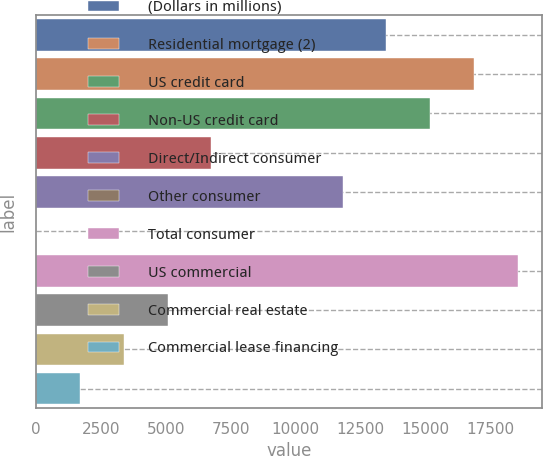Convert chart. <chart><loc_0><loc_0><loc_500><loc_500><bar_chart><fcel>(Dollars in millions)<fcel>Residential mortgage (2)<fcel>US credit card<fcel>Non-US credit card<fcel>Direct/Indirect consumer<fcel>Other consumer<fcel>Total consumer<fcel>US commercial<fcel>Commercial real estate<fcel>Commercial lease financing<nl><fcel>13488.6<fcel>16860<fcel>15174.3<fcel>6745.8<fcel>11802.9<fcel>3<fcel>18545.7<fcel>5060.1<fcel>3374.4<fcel>1688.7<nl></chart> 